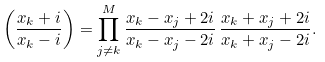Convert formula to latex. <formula><loc_0><loc_0><loc_500><loc_500>\left ( \frac { x _ { k } + i } { x _ { k } - i } \right ) = \prod _ { j \neq k } ^ { M } \frac { x _ { k } - x _ { j } + 2 i } { x _ { k } - x _ { j } - 2 i } \, \frac { x _ { k } + x _ { j } + 2 i } { x _ { k } + x _ { j } - 2 i } .</formula> 